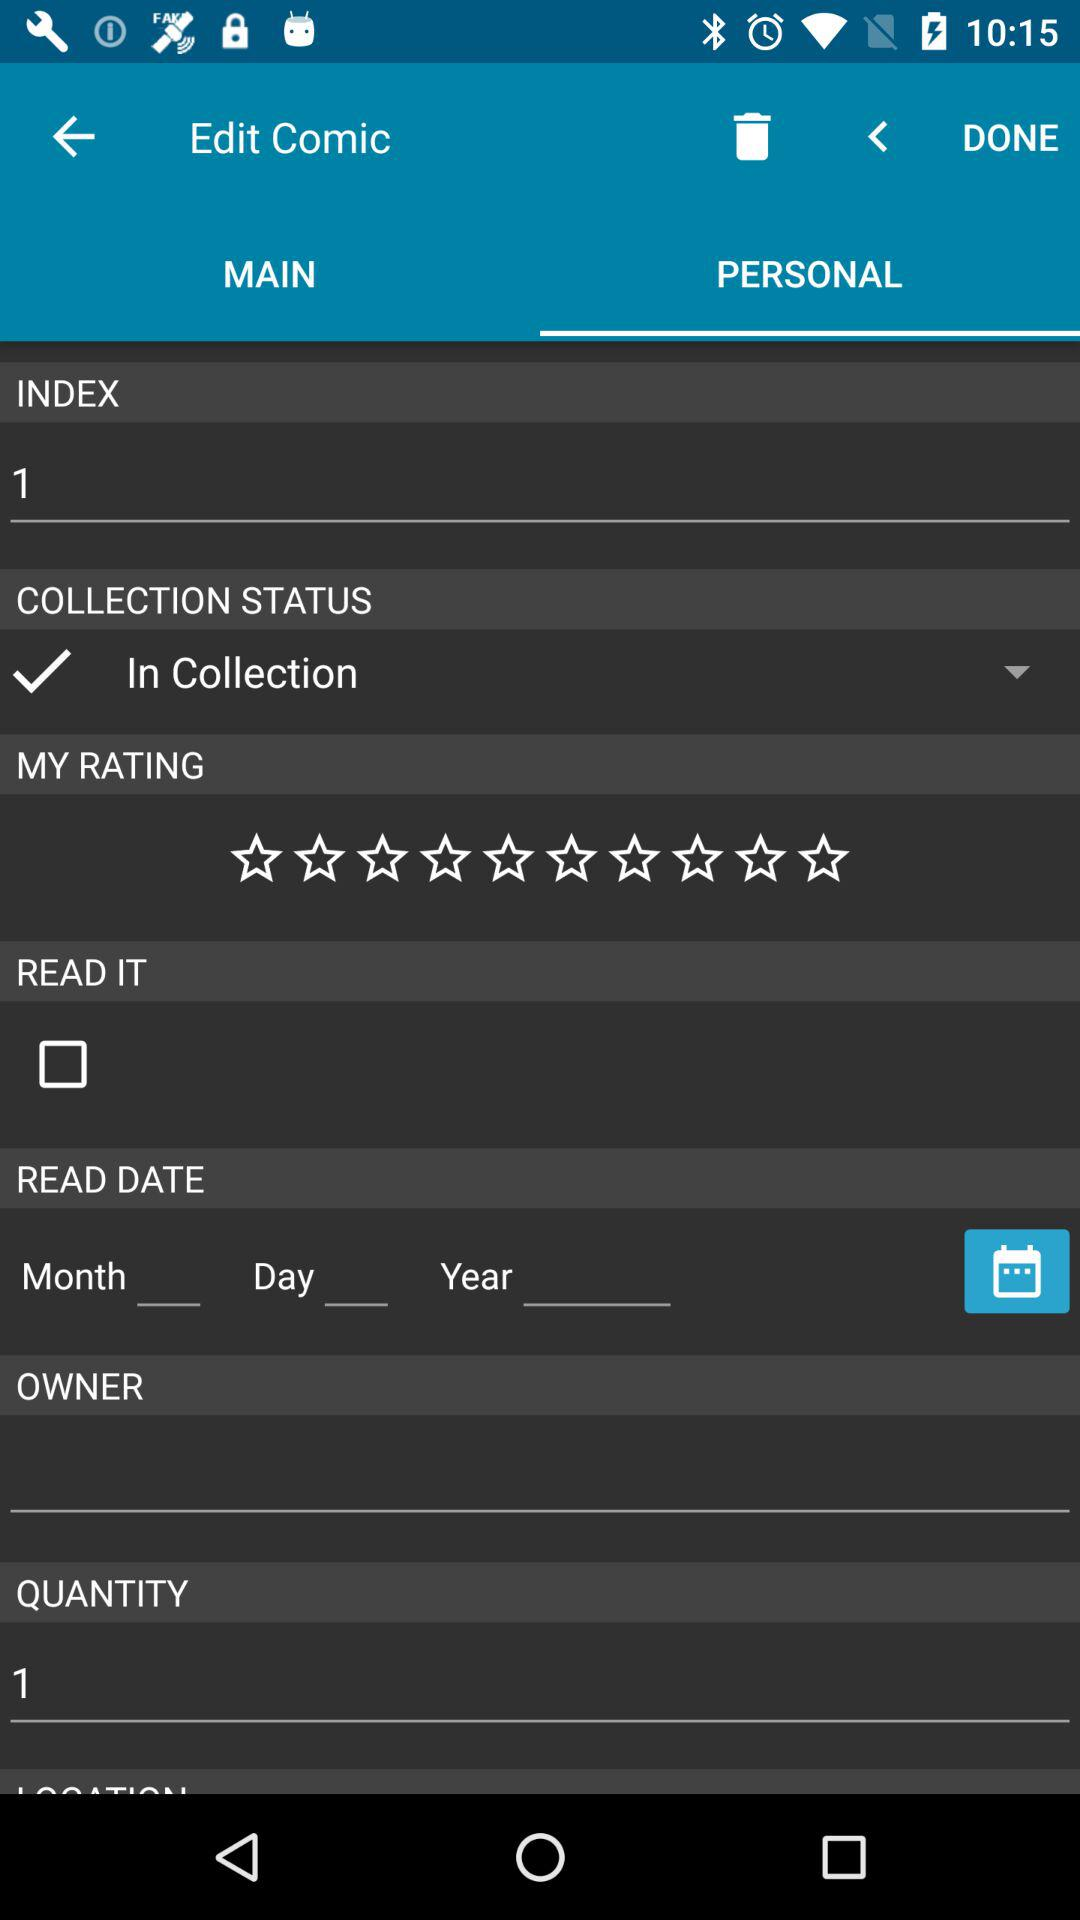Which is the selected "COLLECTION STATUS"? The selected "COLLECTION STATUS" is "In Collection". 